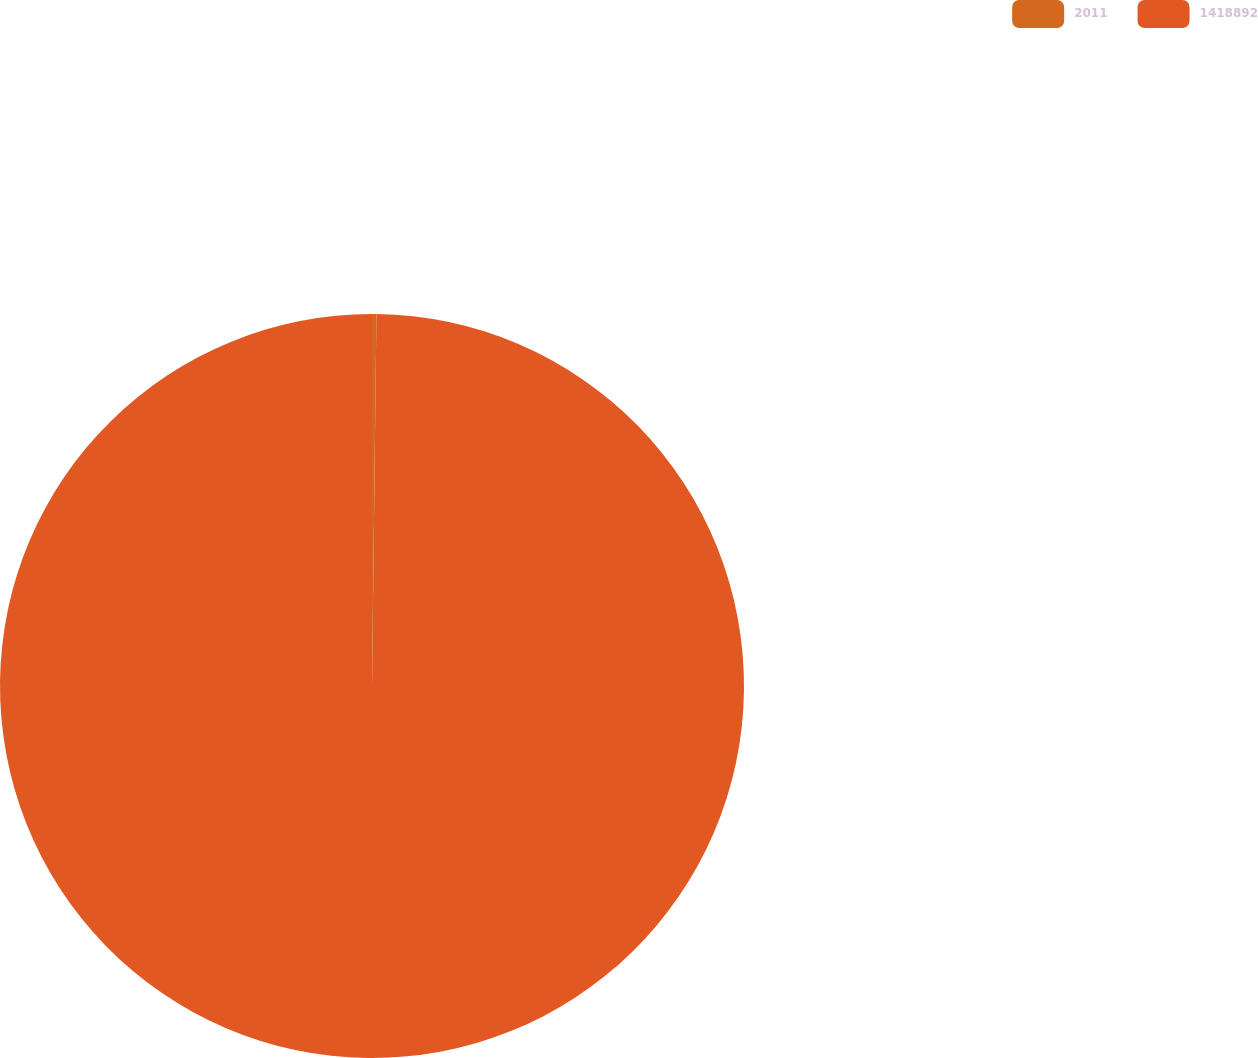Convert chart. <chart><loc_0><loc_0><loc_500><loc_500><pie_chart><fcel>2011<fcel>1418892<nl><fcel>0.19%<fcel>99.81%<nl></chart> 